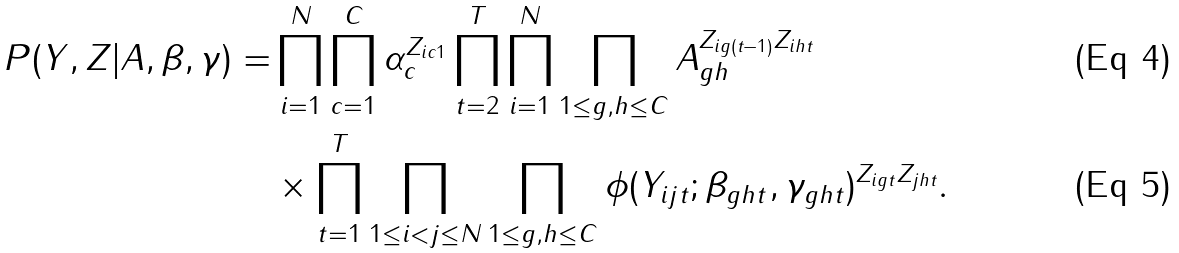Convert formula to latex. <formula><loc_0><loc_0><loc_500><loc_500>P ( { Y } , { Z } | { A } , { \beta } , { \gamma } ) = & \prod _ { i = 1 } ^ { N } \prod _ { c = 1 } ^ { C } \alpha _ { c } ^ { Z _ { i c 1 } } \prod _ { t = 2 } ^ { T } \prod _ { i = 1 } ^ { N } \prod _ { 1 \leq g , h \leq C } A _ { g h } ^ { Z _ { i g ( t - 1 ) } Z _ { i h t } } \\ & \times \prod _ { t = 1 } ^ { T } \prod _ { 1 \leq i < j \leq N } \prod _ { 1 \leq g , h \leq C } \phi ( Y _ { i j t } ; \beta _ { g h t } , \gamma _ { g h t } ) ^ { Z _ { i g t } Z _ { j h t } } .</formula> 